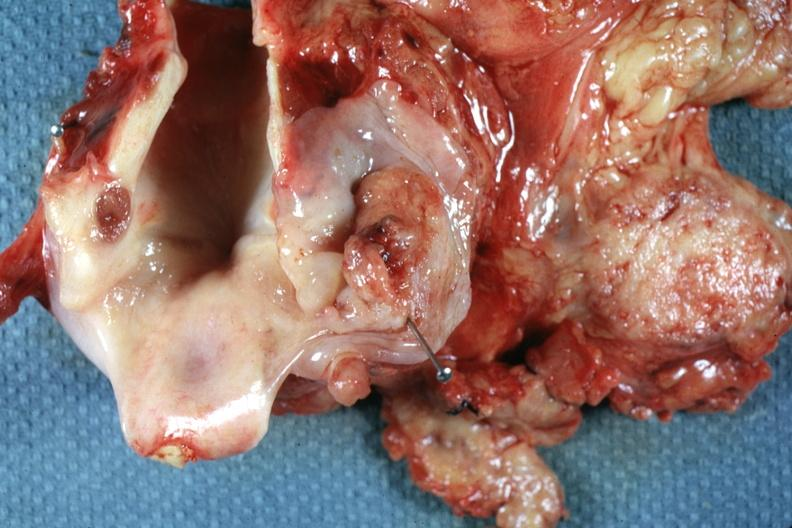what does this image show?
Answer the question using a single word or phrase. Ulcerative lesion right pyriform sinus well shown 